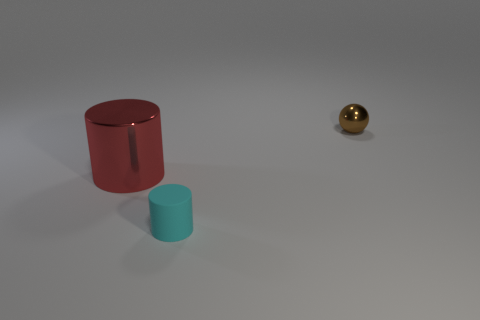There is a thing that is both behind the tiny cyan cylinder and on the right side of the large red object; what material is it?
Make the answer very short. Metal. Do the tiny object that is in front of the brown shiny sphere and the small object behind the matte thing have the same shape?
Your answer should be very brief. No. How many things are objects to the left of the brown metallic object or cyan metallic objects?
Provide a short and direct response. 2. Is the sphere the same size as the cyan object?
Offer a very short reply. Yes. What is the color of the metal object that is left of the small metal ball?
Offer a very short reply. Red. There is a object that is made of the same material as the small brown sphere; what is its size?
Make the answer very short. Large. Does the brown ball have the same size as the cylinder in front of the shiny cylinder?
Offer a very short reply. Yes. There is a object that is in front of the red object; what is it made of?
Make the answer very short. Rubber. What number of small rubber objects are to the right of the shiny object behind the red metallic cylinder?
Your answer should be compact. 0. Is there another object that has the same shape as the small brown object?
Your answer should be compact. No. 